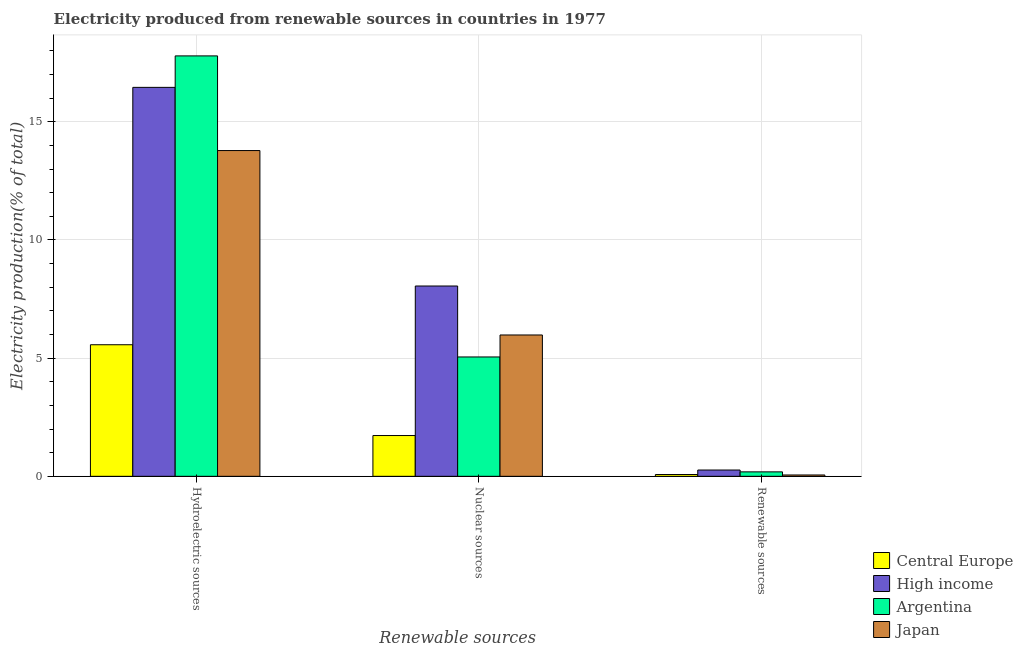Are the number of bars per tick equal to the number of legend labels?
Ensure brevity in your answer.  Yes. Are the number of bars on each tick of the X-axis equal?
Provide a short and direct response. Yes. What is the label of the 1st group of bars from the left?
Keep it short and to the point. Hydroelectric sources. What is the percentage of electricity produced by renewable sources in Argentina?
Keep it short and to the point. 0.19. Across all countries, what is the maximum percentage of electricity produced by renewable sources?
Provide a succinct answer. 0.27. Across all countries, what is the minimum percentage of electricity produced by nuclear sources?
Give a very brief answer. 1.73. In which country was the percentage of electricity produced by hydroelectric sources maximum?
Your answer should be compact. Argentina. In which country was the percentage of electricity produced by renewable sources minimum?
Provide a succinct answer. Japan. What is the total percentage of electricity produced by hydroelectric sources in the graph?
Give a very brief answer. 53.6. What is the difference between the percentage of electricity produced by hydroelectric sources in High income and that in Argentina?
Give a very brief answer. -1.33. What is the difference between the percentage of electricity produced by renewable sources in Japan and the percentage of electricity produced by nuclear sources in Argentina?
Your answer should be compact. -4.99. What is the average percentage of electricity produced by hydroelectric sources per country?
Your answer should be very brief. 13.4. What is the difference between the percentage of electricity produced by renewable sources and percentage of electricity produced by nuclear sources in Argentina?
Your response must be concise. -4.86. In how many countries, is the percentage of electricity produced by renewable sources greater than 3 %?
Provide a short and direct response. 0. What is the ratio of the percentage of electricity produced by nuclear sources in Japan to that in High income?
Give a very brief answer. 0.74. Is the percentage of electricity produced by hydroelectric sources in Argentina less than that in Central Europe?
Provide a short and direct response. No. Is the difference between the percentage of electricity produced by renewable sources in Argentina and Central Europe greater than the difference between the percentage of electricity produced by nuclear sources in Argentina and Central Europe?
Offer a very short reply. No. What is the difference between the highest and the second highest percentage of electricity produced by hydroelectric sources?
Provide a short and direct response. 1.33. What is the difference between the highest and the lowest percentage of electricity produced by hydroelectric sources?
Your response must be concise. 12.22. In how many countries, is the percentage of electricity produced by nuclear sources greater than the average percentage of electricity produced by nuclear sources taken over all countries?
Your answer should be very brief. 2. Is the sum of the percentage of electricity produced by hydroelectric sources in Japan and Central Europe greater than the maximum percentage of electricity produced by renewable sources across all countries?
Ensure brevity in your answer.  Yes. Is it the case that in every country, the sum of the percentage of electricity produced by hydroelectric sources and percentage of electricity produced by nuclear sources is greater than the percentage of electricity produced by renewable sources?
Give a very brief answer. Yes. How many bars are there?
Make the answer very short. 12. How many countries are there in the graph?
Provide a short and direct response. 4. Does the graph contain grids?
Your answer should be compact. Yes. How many legend labels are there?
Keep it short and to the point. 4. What is the title of the graph?
Your answer should be compact. Electricity produced from renewable sources in countries in 1977. What is the label or title of the X-axis?
Ensure brevity in your answer.  Renewable sources. What is the Electricity production(% of total) in Central Europe in Hydroelectric sources?
Your answer should be very brief. 5.57. What is the Electricity production(% of total) in High income in Hydroelectric sources?
Ensure brevity in your answer.  16.46. What is the Electricity production(% of total) in Argentina in Hydroelectric sources?
Your answer should be very brief. 17.79. What is the Electricity production(% of total) of Japan in Hydroelectric sources?
Give a very brief answer. 13.78. What is the Electricity production(% of total) in Central Europe in Nuclear sources?
Provide a short and direct response. 1.73. What is the Electricity production(% of total) in High income in Nuclear sources?
Ensure brevity in your answer.  8.05. What is the Electricity production(% of total) of Argentina in Nuclear sources?
Your response must be concise. 5.05. What is the Electricity production(% of total) of Japan in Nuclear sources?
Offer a terse response. 5.98. What is the Electricity production(% of total) of Central Europe in Renewable sources?
Make the answer very short. 0.08. What is the Electricity production(% of total) in High income in Renewable sources?
Give a very brief answer. 0.27. What is the Electricity production(% of total) in Argentina in Renewable sources?
Ensure brevity in your answer.  0.19. What is the Electricity production(% of total) of Japan in Renewable sources?
Ensure brevity in your answer.  0.06. Across all Renewable sources, what is the maximum Electricity production(% of total) of Central Europe?
Offer a terse response. 5.57. Across all Renewable sources, what is the maximum Electricity production(% of total) of High income?
Provide a succinct answer. 16.46. Across all Renewable sources, what is the maximum Electricity production(% of total) of Argentina?
Your answer should be very brief. 17.79. Across all Renewable sources, what is the maximum Electricity production(% of total) in Japan?
Provide a succinct answer. 13.78. Across all Renewable sources, what is the minimum Electricity production(% of total) in Central Europe?
Your answer should be compact. 0.08. Across all Renewable sources, what is the minimum Electricity production(% of total) in High income?
Your answer should be compact. 0.27. Across all Renewable sources, what is the minimum Electricity production(% of total) in Argentina?
Provide a succinct answer. 0.19. Across all Renewable sources, what is the minimum Electricity production(% of total) of Japan?
Offer a terse response. 0.06. What is the total Electricity production(% of total) in Central Europe in the graph?
Provide a succinct answer. 7.37. What is the total Electricity production(% of total) of High income in the graph?
Provide a succinct answer. 24.78. What is the total Electricity production(% of total) of Argentina in the graph?
Your response must be concise. 23.03. What is the total Electricity production(% of total) in Japan in the graph?
Provide a succinct answer. 19.82. What is the difference between the Electricity production(% of total) in Central Europe in Hydroelectric sources and that in Nuclear sources?
Offer a very short reply. 3.84. What is the difference between the Electricity production(% of total) in High income in Hydroelectric sources and that in Nuclear sources?
Offer a terse response. 8.4. What is the difference between the Electricity production(% of total) of Argentina in Hydroelectric sources and that in Nuclear sources?
Your answer should be compact. 12.74. What is the difference between the Electricity production(% of total) in Japan in Hydroelectric sources and that in Nuclear sources?
Offer a very short reply. 7.8. What is the difference between the Electricity production(% of total) of Central Europe in Hydroelectric sources and that in Renewable sources?
Make the answer very short. 5.49. What is the difference between the Electricity production(% of total) of High income in Hydroelectric sources and that in Renewable sources?
Give a very brief answer. 16.19. What is the difference between the Electricity production(% of total) of Argentina in Hydroelectric sources and that in Renewable sources?
Your response must be concise. 17.6. What is the difference between the Electricity production(% of total) of Japan in Hydroelectric sources and that in Renewable sources?
Your answer should be compact. 13.73. What is the difference between the Electricity production(% of total) in Central Europe in Nuclear sources and that in Renewable sources?
Your answer should be compact. 1.65. What is the difference between the Electricity production(% of total) in High income in Nuclear sources and that in Renewable sources?
Offer a terse response. 7.79. What is the difference between the Electricity production(% of total) in Argentina in Nuclear sources and that in Renewable sources?
Provide a succinct answer. 4.86. What is the difference between the Electricity production(% of total) in Japan in Nuclear sources and that in Renewable sources?
Your answer should be very brief. 5.92. What is the difference between the Electricity production(% of total) of Central Europe in Hydroelectric sources and the Electricity production(% of total) of High income in Nuclear sources?
Offer a terse response. -2.49. What is the difference between the Electricity production(% of total) in Central Europe in Hydroelectric sources and the Electricity production(% of total) in Argentina in Nuclear sources?
Give a very brief answer. 0.52. What is the difference between the Electricity production(% of total) in Central Europe in Hydroelectric sources and the Electricity production(% of total) in Japan in Nuclear sources?
Your response must be concise. -0.41. What is the difference between the Electricity production(% of total) of High income in Hydroelectric sources and the Electricity production(% of total) of Argentina in Nuclear sources?
Keep it short and to the point. 11.41. What is the difference between the Electricity production(% of total) of High income in Hydroelectric sources and the Electricity production(% of total) of Japan in Nuclear sources?
Keep it short and to the point. 10.48. What is the difference between the Electricity production(% of total) in Argentina in Hydroelectric sources and the Electricity production(% of total) in Japan in Nuclear sources?
Provide a short and direct response. 11.81. What is the difference between the Electricity production(% of total) of Central Europe in Hydroelectric sources and the Electricity production(% of total) of High income in Renewable sources?
Make the answer very short. 5.3. What is the difference between the Electricity production(% of total) in Central Europe in Hydroelectric sources and the Electricity production(% of total) in Argentina in Renewable sources?
Ensure brevity in your answer.  5.38. What is the difference between the Electricity production(% of total) of Central Europe in Hydroelectric sources and the Electricity production(% of total) of Japan in Renewable sources?
Offer a very short reply. 5.51. What is the difference between the Electricity production(% of total) in High income in Hydroelectric sources and the Electricity production(% of total) in Argentina in Renewable sources?
Provide a succinct answer. 16.27. What is the difference between the Electricity production(% of total) of High income in Hydroelectric sources and the Electricity production(% of total) of Japan in Renewable sources?
Make the answer very short. 16.4. What is the difference between the Electricity production(% of total) in Argentina in Hydroelectric sources and the Electricity production(% of total) in Japan in Renewable sources?
Your answer should be compact. 17.73. What is the difference between the Electricity production(% of total) in Central Europe in Nuclear sources and the Electricity production(% of total) in High income in Renewable sources?
Your answer should be very brief. 1.46. What is the difference between the Electricity production(% of total) of Central Europe in Nuclear sources and the Electricity production(% of total) of Argentina in Renewable sources?
Provide a succinct answer. 1.54. What is the difference between the Electricity production(% of total) of Central Europe in Nuclear sources and the Electricity production(% of total) of Japan in Renewable sources?
Offer a very short reply. 1.67. What is the difference between the Electricity production(% of total) of High income in Nuclear sources and the Electricity production(% of total) of Argentina in Renewable sources?
Make the answer very short. 7.86. What is the difference between the Electricity production(% of total) of High income in Nuclear sources and the Electricity production(% of total) of Japan in Renewable sources?
Provide a short and direct response. 8. What is the difference between the Electricity production(% of total) of Argentina in Nuclear sources and the Electricity production(% of total) of Japan in Renewable sources?
Give a very brief answer. 4.99. What is the average Electricity production(% of total) of Central Europe per Renewable sources?
Your answer should be very brief. 2.46. What is the average Electricity production(% of total) of High income per Renewable sources?
Your answer should be very brief. 8.26. What is the average Electricity production(% of total) in Argentina per Renewable sources?
Make the answer very short. 7.68. What is the average Electricity production(% of total) of Japan per Renewable sources?
Keep it short and to the point. 6.61. What is the difference between the Electricity production(% of total) in Central Europe and Electricity production(% of total) in High income in Hydroelectric sources?
Provide a short and direct response. -10.89. What is the difference between the Electricity production(% of total) in Central Europe and Electricity production(% of total) in Argentina in Hydroelectric sources?
Make the answer very short. -12.22. What is the difference between the Electricity production(% of total) of Central Europe and Electricity production(% of total) of Japan in Hydroelectric sources?
Offer a terse response. -8.22. What is the difference between the Electricity production(% of total) in High income and Electricity production(% of total) in Argentina in Hydroelectric sources?
Ensure brevity in your answer.  -1.33. What is the difference between the Electricity production(% of total) of High income and Electricity production(% of total) of Japan in Hydroelectric sources?
Provide a short and direct response. 2.67. What is the difference between the Electricity production(% of total) of Argentina and Electricity production(% of total) of Japan in Hydroelectric sources?
Your answer should be very brief. 4.01. What is the difference between the Electricity production(% of total) in Central Europe and Electricity production(% of total) in High income in Nuclear sources?
Provide a short and direct response. -6.33. What is the difference between the Electricity production(% of total) in Central Europe and Electricity production(% of total) in Argentina in Nuclear sources?
Make the answer very short. -3.33. What is the difference between the Electricity production(% of total) of Central Europe and Electricity production(% of total) of Japan in Nuclear sources?
Your answer should be compact. -4.26. What is the difference between the Electricity production(% of total) in High income and Electricity production(% of total) in Argentina in Nuclear sources?
Your answer should be very brief. 3. What is the difference between the Electricity production(% of total) of High income and Electricity production(% of total) of Japan in Nuclear sources?
Your answer should be very brief. 2.07. What is the difference between the Electricity production(% of total) in Argentina and Electricity production(% of total) in Japan in Nuclear sources?
Provide a short and direct response. -0.93. What is the difference between the Electricity production(% of total) in Central Europe and Electricity production(% of total) in High income in Renewable sources?
Offer a terse response. -0.19. What is the difference between the Electricity production(% of total) in Central Europe and Electricity production(% of total) in Argentina in Renewable sources?
Provide a succinct answer. -0.11. What is the difference between the Electricity production(% of total) of Central Europe and Electricity production(% of total) of Japan in Renewable sources?
Offer a very short reply. 0.02. What is the difference between the Electricity production(% of total) of High income and Electricity production(% of total) of Argentina in Renewable sources?
Provide a succinct answer. 0.08. What is the difference between the Electricity production(% of total) in High income and Electricity production(% of total) in Japan in Renewable sources?
Offer a very short reply. 0.21. What is the difference between the Electricity production(% of total) of Argentina and Electricity production(% of total) of Japan in Renewable sources?
Give a very brief answer. 0.13. What is the ratio of the Electricity production(% of total) in Central Europe in Hydroelectric sources to that in Nuclear sources?
Provide a succinct answer. 3.23. What is the ratio of the Electricity production(% of total) of High income in Hydroelectric sources to that in Nuclear sources?
Keep it short and to the point. 2.04. What is the ratio of the Electricity production(% of total) of Argentina in Hydroelectric sources to that in Nuclear sources?
Give a very brief answer. 3.52. What is the ratio of the Electricity production(% of total) of Japan in Hydroelectric sources to that in Nuclear sources?
Your answer should be very brief. 2.3. What is the ratio of the Electricity production(% of total) of Central Europe in Hydroelectric sources to that in Renewable sources?
Your answer should be very brief. 73.04. What is the ratio of the Electricity production(% of total) of High income in Hydroelectric sources to that in Renewable sources?
Provide a short and direct response. 61.84. What is the ratio of the Electricity production(% of total) of Argentina in Hydroelectric sources to that in Renewable sources?
Provide a succinct answer. 94.52. What is the ratio of the Electricity production(% of total) of Japan in Hydroelectric sources to that in Renewable sources?
Give a very brief answer. 243.23. What is the ratio of the Electricity production(% of total) in Central Europe in Nuclear sources to that in Renewable sources?
Offer a very short reply. 22.63. What is the ratio of the Electricity production(% of total) of High income in Nuclear sources to that in Renewable sources?
Provide a succinct answer. 30.26. What is the ratio of the Electricity production(% of total) of Argentina in Nuclear sources to that in Renewable sources?
Provide a succinct answer. 26.84. What is the ratio of the Electricity production(% of total) in Japan in Nuclear sources to that in Renewable sources?
Keep it short and to the point. 105.53. What is the difference between the highest and the second highest Electricity production(% of total) of Central Europe?
Provide a succinct answer. 3.84. What is the difference between the highest and the second highest Electricity production(% of total) in High income?
Offer a terse response. 8.4. What is the difference between the highest and the second highest Electricity production(% of total) in Argentina?
Ensure brevity in your answer.  12.74. What is the difference between the highest and the second highest Electricity production(% of total) of Japan?
Give a very brief answer. 7.8. What is the difference between the highest and the lowest Electricity production(% of total) of Central Europe?
Give a very brief answer. 5.49. What is the difference between the highest and the lowest Electricity production(% of total) of High income?
Your answer should be very brief. 16.19. What is the difference between the highest and the lowest Electricity production(% of total) in Argentina?
Your answer should be compact. 17.6. What is the difference between the highest and the lowest Electricity production(% of total) in Japan?
Provide a short and direct response. 13.73. 